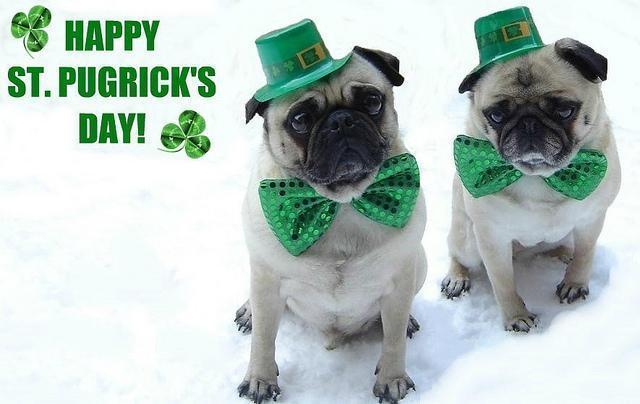How many animals are in the picture?
Give a very brief answer. 2. How many dogs are visible?
Give a very brief answer. 2. How many ties can be seen?
Give a very brief answer. 2. How many bears are there?
Give a very brief answer. 0. 